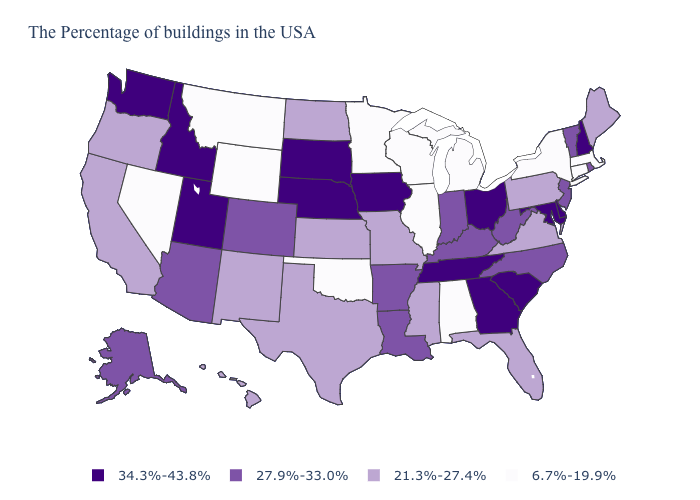Does Missouri have the same value as Hawaii?
Concise answer only. Yes. Which states have the lowest value in the USA?
Write a very short answer. Massachusetts, Connecticut, New York, Michigan, Alabama, Wisconsin, Illinois, Minnesota, Oklahoma, Wyoming, Montana, Nevada. What is the value of Illinois?
Give a very brief answer. 6.7%-19.9%. Name the states that have a value in the range 27.9%-33.0%?
Short answer required. Rhode Island, Vermont, New Jersey, North Carolina, West Virginia, Kentucky, Indiana, Louisiana, Arkansas, Colorado, Arizona, Alaska. Does the map have missing data?
Write a very short answer. No. What is the value of Utah?
Keep it brief. 34.3%-43.8%. What is the value of South Carolina?
Quick response, please. 34.3%-43.8%. Which states have the lowest value in the MidWest?
Concise answer only. Michigan, Wisconsin, Illinois, Minnesota. How many symbols are there in the legend?
Concise answer only. 4. What is the value of Arizona?
Be succinct. 27.9%-33.0%. What is the highest value in the USA?
Short answer required. 34.3%-43.8%. Does Oregon have the highest value in the West?
Give a very brief answer. No. Name the states that have a value in the range 6.7%-19.9%?
Short answer required. Massachusetts, Connecticut, New York, Michigan, Alabama, Wisconsin, Illinois, Minnesota, Oklahoma, Wyoming, Montana, Nevada. Name the states that have a value in the range 34.3%-43.8%?
Short answer required. New Hampshire, Delaware, Maryland, South Carolina, Ohio, Georgia, Tennessee, Iowa, Nebraska, South Dakota, Utah, Idaho, Washington. 